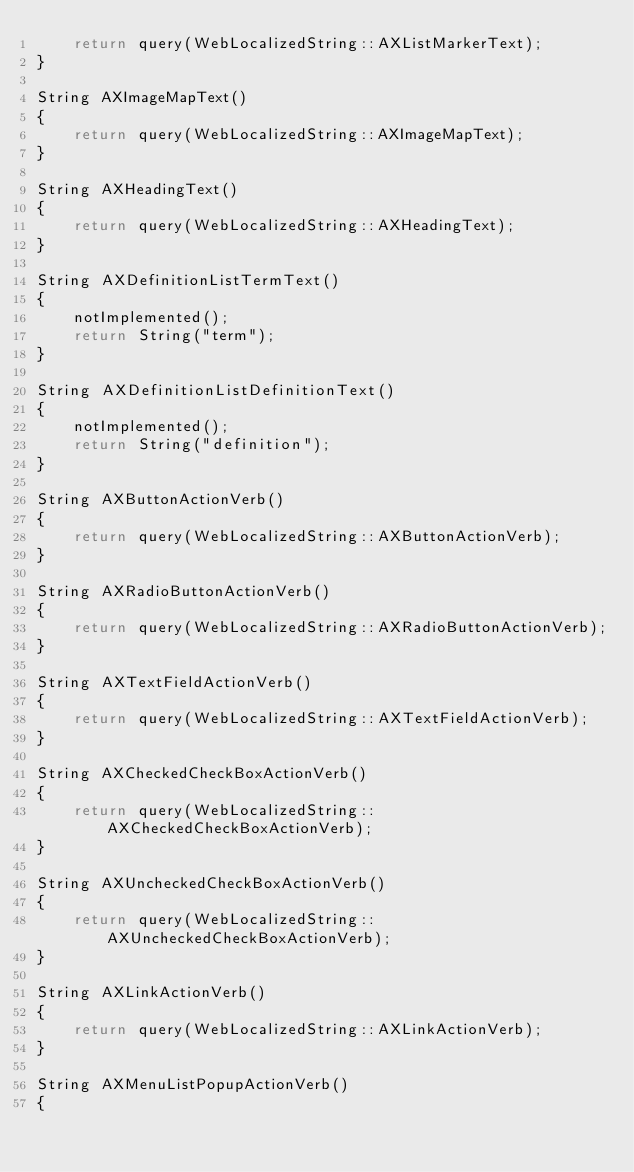<code> <loc_0><loc_0><loc_500><loc_500><_C++_>    return query(WebLocalizedString::AXListMarkerText);
}

String AXImageMapText()
{
    return query(WebLocalizedString::AXImageMapText);
}

String AXHeadingText()
{
    return query(WebLocalizedString::AXHeadingText);
}

String AXDefinitionListTermText()
{
    notImplemented();
    return String("term");
}

String AXDefinitionListDefinitionText()
{
    notImplemented();
    return String("definition");
}

String AXButtonActionVerb()
{
    return query(WebLocalizedString::AXButtonActionVerb);
}

String AXRadioButtonActionVerb()
{
    return query(WebLocalizedString::AXRadioButtonActionVerb);
}

String AXTextFieldActionVerb()
{
    return query(WebLocalizedString::AXTextFieldActionVerb);
}

String AXCheckedCheckBoxActionVerb()
{
    return query(WebLocalizedString::AXCheckedCheckBoxActionVerb);
}

String AXUncheckedCheckBoxActionVerb()
{
    return query(WebLocalizedString::AXUncheckedCheckBoxActionVerb);
}

String AXLinkActionVerb()
{
    return query(WebLocalizedString::AXLinkActionVerb);
}

String AXMenuListPopupActionVerb()
{</code> 